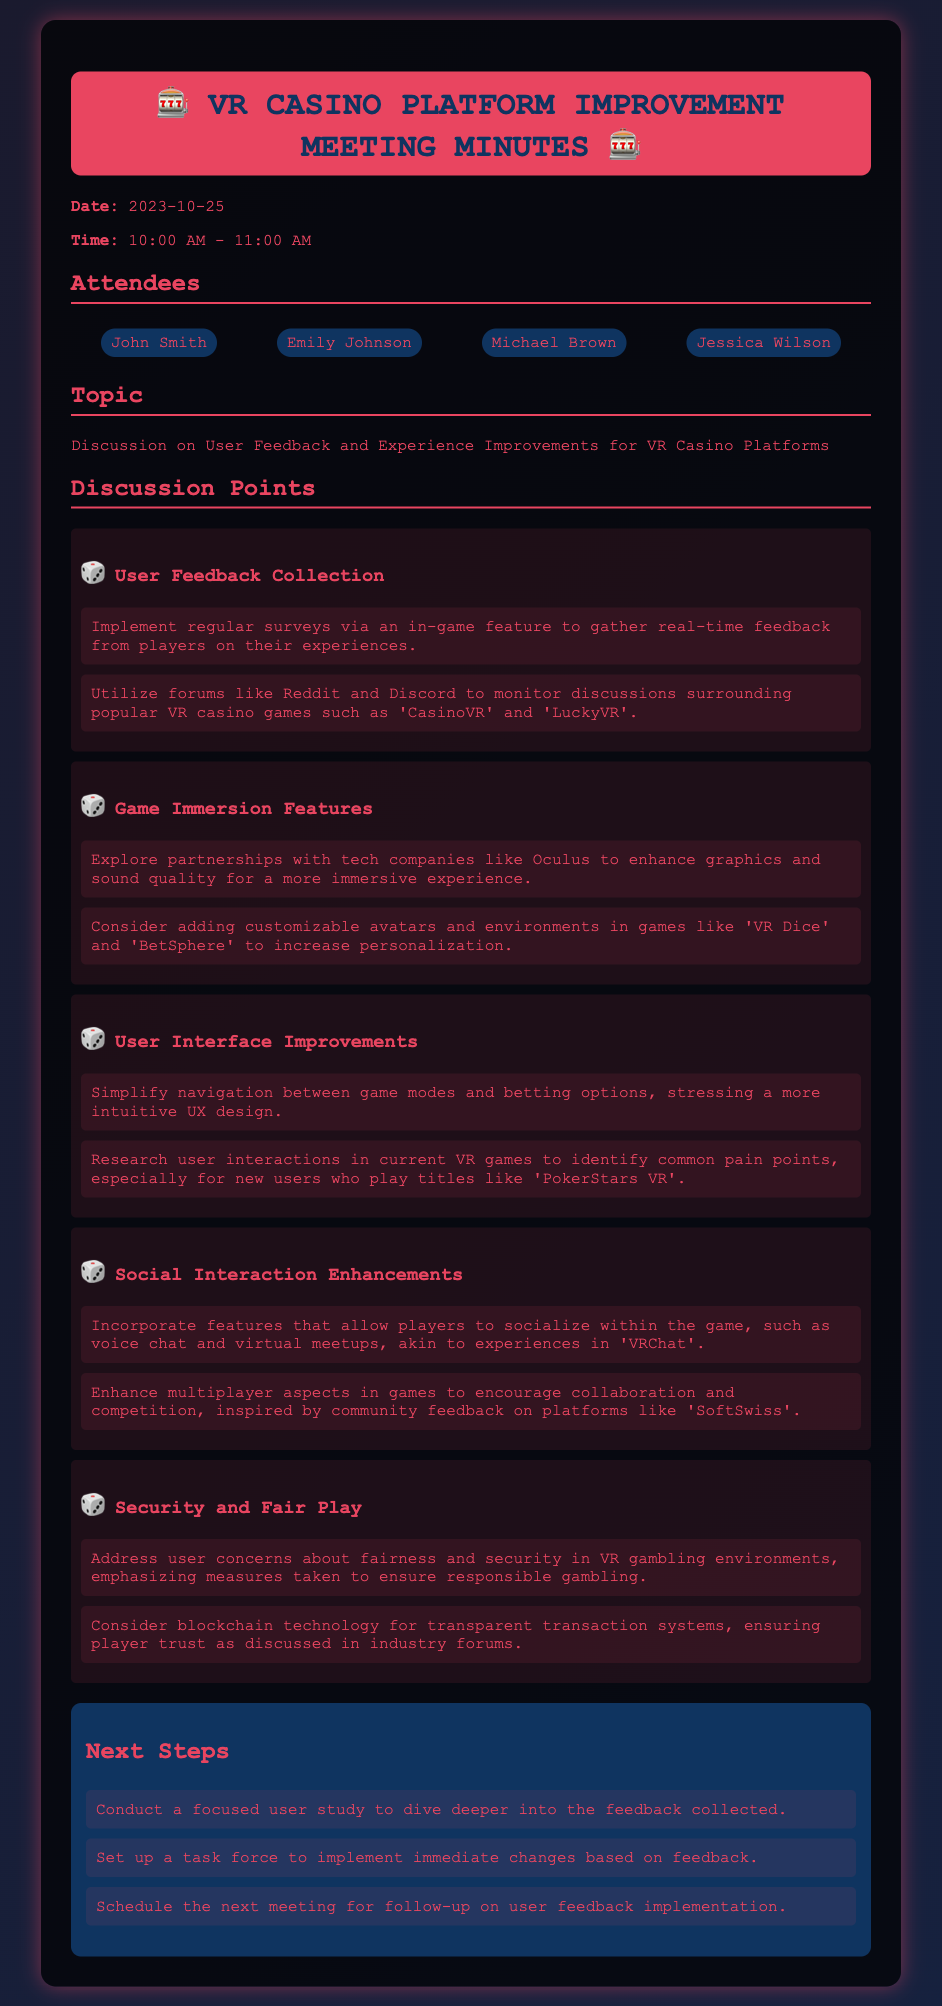what is the date of the meeting? The date of the meeting is mentioned at the beginning of the document.
Answer: 2023-10-25 who are the attendees? The attendees are listed in a section under "Attendees".
Answer: John Smith, Emily Johnson, Michael Brown, Jessica Wilson what is the main topic of the discussion? The main topic is outlined in the "Topic" section of the document.
Answer: Discussion on User Feedback and Experience Improvements for VR Casino Platforms how many discussion points are there? The number of discussion points is indicated by the list under "Discussion Points".
Answer: Five which technology is suggested for improving graphics? The technology suggested is mentioned in the discussion about game immersion features.
Answer: Oculus what is one proposed feature for social interaction enhancements? This is found in the discussion about social interaction enhancements.
Answer: Voice chat what is the purpose of the focused user study? The purpose is outlined in the "Next Steps" section regarding user feedback.
Answer: To dive deeper into the feedback collected what will be set up to implement immediate changes? This pertains to the action items in the "Next Steps" section.
Answer: A task force when is the next meeting scheduled? The timing of the next meeting is mentioned as part of the next steps to follow up.
Answer: For follow-up on user feedback implementation 